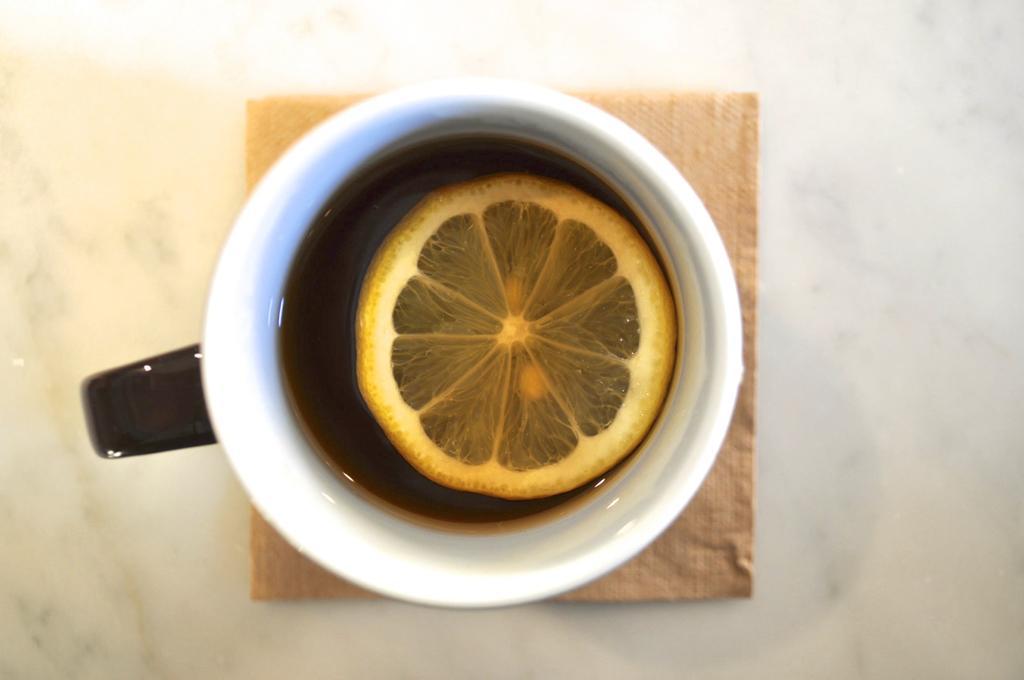Please provide a concise description of this image. In this image, we can see a cup on the tissue. This cup contains a lemon. 